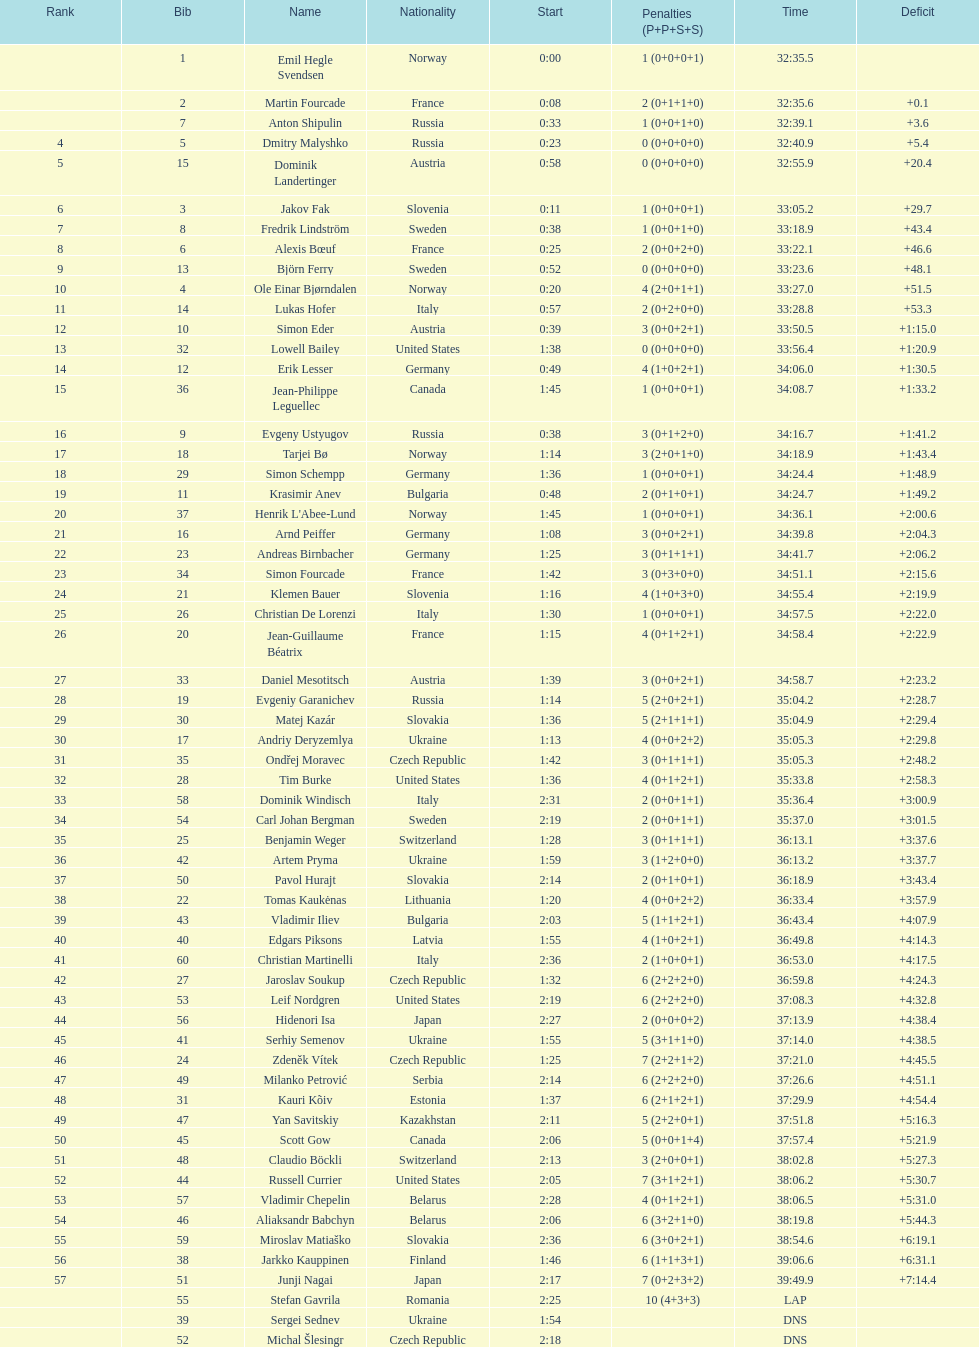Who is the highest ranked swedish runner? Fredrik Lindström. 